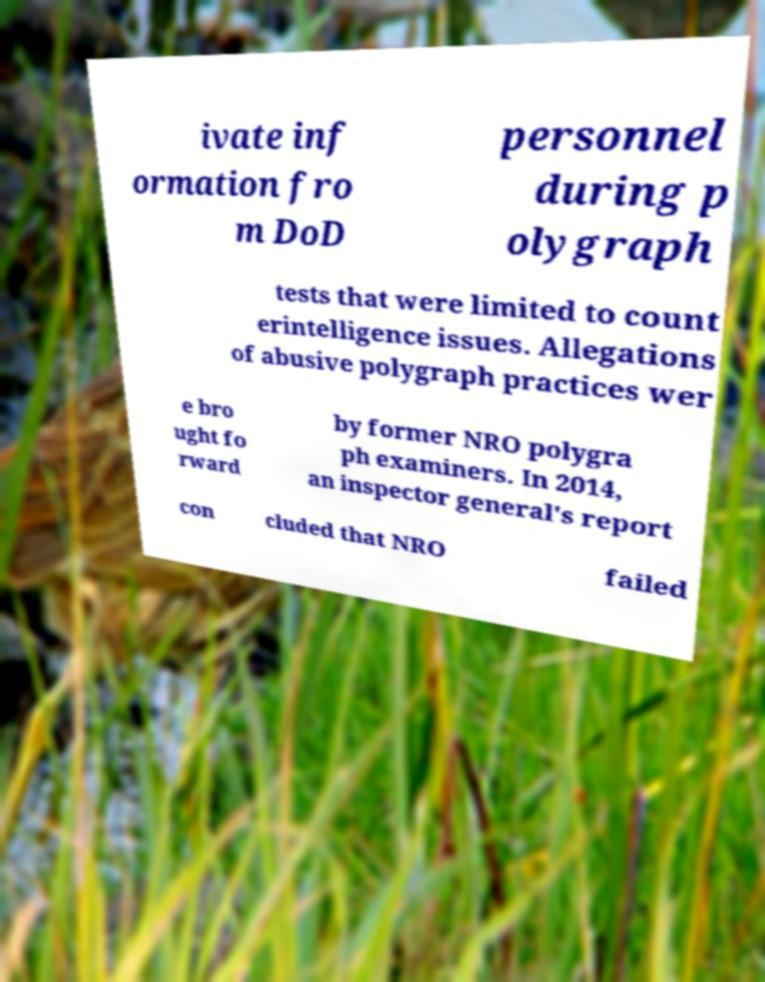Please read and relay the text visible in this image. What does it say? ivate inf ormation fro m DoD personnel during p olygraph tests that were limited to count erintelligence issues. Allegations of abusive polygraph practices wer e bro ught fo rward by former NRO polygra ph examiners. In 2014, an inspector general's report con cluded that NRO failed 